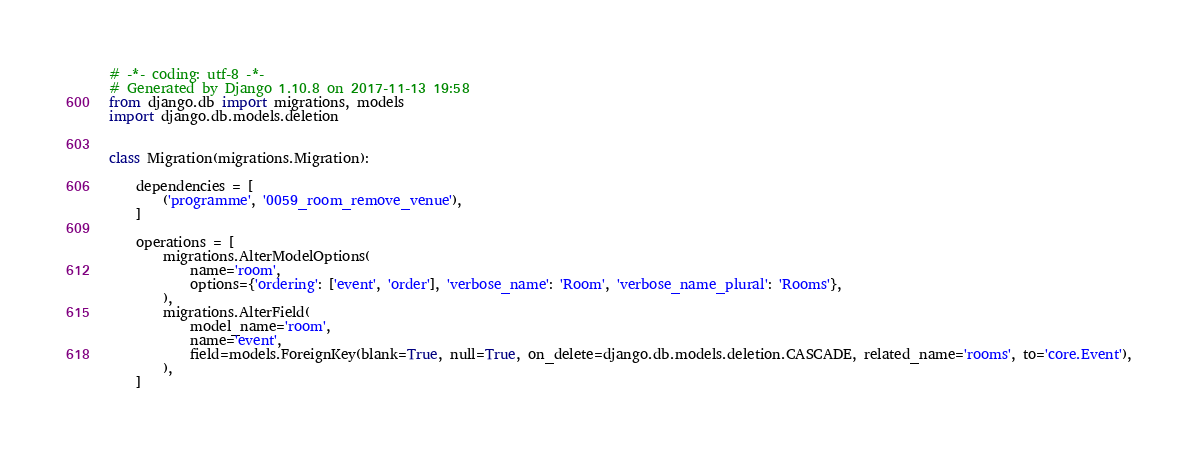Convert code to text. <code><loc_0><loc_0><loc_500><loc_500><_Python_># -*- coding: utf-8 -*-
# Generated by Django 1.10.8 on 2017-11-13 19:58
from django.db import migrations, models
import django.db.models.deletion


class Migration(migrations.Migration):

    dependencies = [
        ('programme', '0059_room_remove_venue'),
    ]

    operations = [
        migrations.AlterModelOptions(
            name='room',
            options={'ordering': ['event', 'order'], 'verbose_name': 'Room', 'verbose_name_plural': 'Rooms'},
        ),
        migrations.AlterField(
            model_name='room',
            name='event',
            field=models.ForeignKey(blank=True, null=True, on_delete=django.db.models.deletion.CASCADE, related_name='rooms', to='core.Event'),
        ),
    ]
</code> 